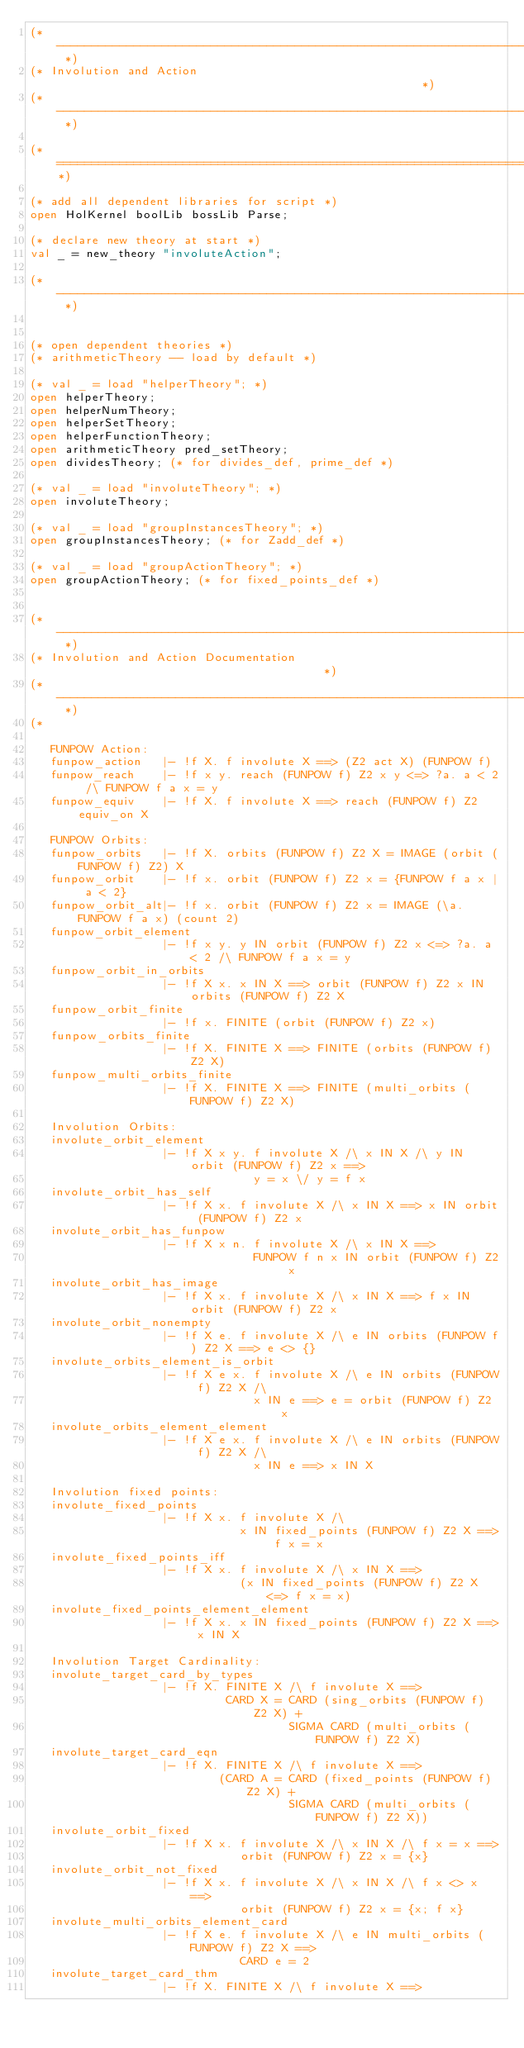<code> <loc_0><loc_0><loc_500><loc_500><_SML_>(* ------------------------------------------------------------------------- *)
(* Involution and Action                                                     *)
(* ------------------------------------------------------------------------- *)

(*===========================================================================*)

(* add all dependent libraries for script *)
open HolKernel boolLib bossLib Parse;

(* declare new theory at start *)
val _ = new_theory "involuteAction";

(* ------------------------------------------------------------------------- *)


(* open dependent theories *)
(* arithmeticTheory -- load by default *)

(* val _ = load "helperTheory"; *)
open helperTheory;
open helperNumTheory;
open helperSetTheory;
open helperFunctionTheory;
open arithmeticTheory pred_setTheory;
open dividesTheory; (* for divides_def, prime_def *)

(* val _ = load "involuteTheory"; *)
open involuteTheory;

(* val _ = load "groupInstancesTheory"; *)
open groupInstancesTheory; (* for Zadd_def *)

(* val _ = load "groupActionTheory"; *)
open groupActionTheory; (* for fixed_points_def *)


(* ------------------------------------------------------------------------- *)
(* Involution and Action Documentation                                       *)
(* ------------------------------------------------------------------------- *)
(*

   FUNPOW Action:
   funpow_action   |- !f X. f involute X ==> (Z2 act X) (FUNPOW f)
   funpow_reach    |- !f x y. reach (FUNPOW f) Z2 x y <=> ?a. a < 2 /\ FUNPOW f a x = y
   funpow_equiv    |- !f X. f involute X ==> reach (FUNPOW f) Z2 equiv_on X

   FUNPOW Orbits:
   funpow_orbits   |- !f X. orbits (FUNPOW f) Z2 X = IMAGE (orbit (FUNPOW f) Z2) X
   funpow_orbit    |- !f x. orbit (FUNPOW f) Z2 x = {FUNPOW f a x | a < 2}
   funpow_orbit_alt|- !f x. orbit (FUNPOW f) Z2 x = IMAGE (\a. FUNPOW f a x) (count 2)
   funpow_orbit_element
                   |- !f x y. y IN orbit (FUNPOW f) Z2 x <=> ?a. a < 2 /\ FUNPOW f a x = y
   funpow_orbit_in_orbits
                   |- !f X x. x IN X ==> orbit (FUNPOW f) Z2 x IN orbits (FUNPOW f) Z2 X
   funpow_orbit_finite
                   |- !f x. FINITE (orbit (FUNPOW f) Z2 x)
   funpow_orbits_finite
                   |- !f X. FINITE X ==> FINITE (orbits (FUNPOW f) Z2 X)
   funpow_multi_orbits_finite
                   |- !f X. FINITE X ==> FINITE (multi_orbits (FUNPOW f) Z2 X)

   Involution Orbits:
   involute_orbit_element
                   |- !f X x y. f involute X /\ x IN X /\ y IN orbit (FUNPOW f) Z2 x ==>
                                y = x \/ y = f x
   involute_orbit_has_self
                   |- !f X x. f involute X /\ x IN X ==> x IN orbit (FUNPOW f) Z2 x
   involute_orbit_has_funpow
                   |- !f X x n. f involute X /\ x IN X ==>
                                FUNPOW f n x IN orbit (FUNPOW f) Z2 x
   involute_orbit_has_image
                   |- !f X x. f involute X /\ x IN X ==> f x IN orbit (FUNPOW f) Z2 x
   involute_orbit_nonempty
                   |- !f X e. f involute X /\ e IN orbits (FUNPOW f) Z2 X ==> e <> {}
   involute_orbits_element_is_orbit
                   |- !f X e x. f involute X /\ e IN orbits (FUNPOW f) Z2 X /\
                                x IN e ==> e = orbit (FUNPOW f) Z2 x
   involute_orbits_element_element
                   |- !f X e x. f involute X /\ e IN orbits (FUNPOW f) Z2 X /\
                                x IN e ==> x IN X

   Involution fixed points:
   involute_fixed_points
                   |- !f X x. f involute X /\
                              x IN fixed_points (FUNPOW f) Z2 X ==> f x = x
   involute_fixed_points_iff
                   |- !f X x. f involute X /\ x IN X ==>
                              (x IN fixed_points (FUNPOW f) Z2 X <=> f x = x)
   involute_fixed_points_element_element
                   |- !f X x. x IN fixed_points (FUNPOW f) Z2 X ==> x IN X

   Involution Target Cardinality:
   involute_target_card_by_types
                   |- !f X. FINITE X /\ f involute X ==>
                            CARD X = CARD (sing_orbits (FUNPOW f) Z2 X) +
                                     SIGMA CARD (multi_orbits (FUNPOW f) Z2 X)
   involute_target_card_eqn
                   |- !f X. FINITE X /\ f involute X ==>
                           (CARD A = CARD (fixed_points (FUNPOW f) Z2 X) +
                                     SIGMA CARD (multi_orbits (FUNPOW f) Z2 X))
   involute_orbit_fixed
                   |- !f X x. f involute X /\ x IN X /\ f x = x ==>
                              orbit (FUNPOW f) Z2 x = {x}
   involute_orbit_not_fixed
                   |- !f X x. f involute X /\ x IN X /\ f x <> x ==>
                              orbit (FUNPOW f) Z2 x = {x; f x}
   involute_multi_orbits_element_card
                   |- !f X e. f involute X /\ e IN multi_orbits (FUNPOW f) Z2 X ==>
                              CARD e = 2
   involute_target_card_thm
                   |- !f X. FINITE X /\ f involute X ==></code> 